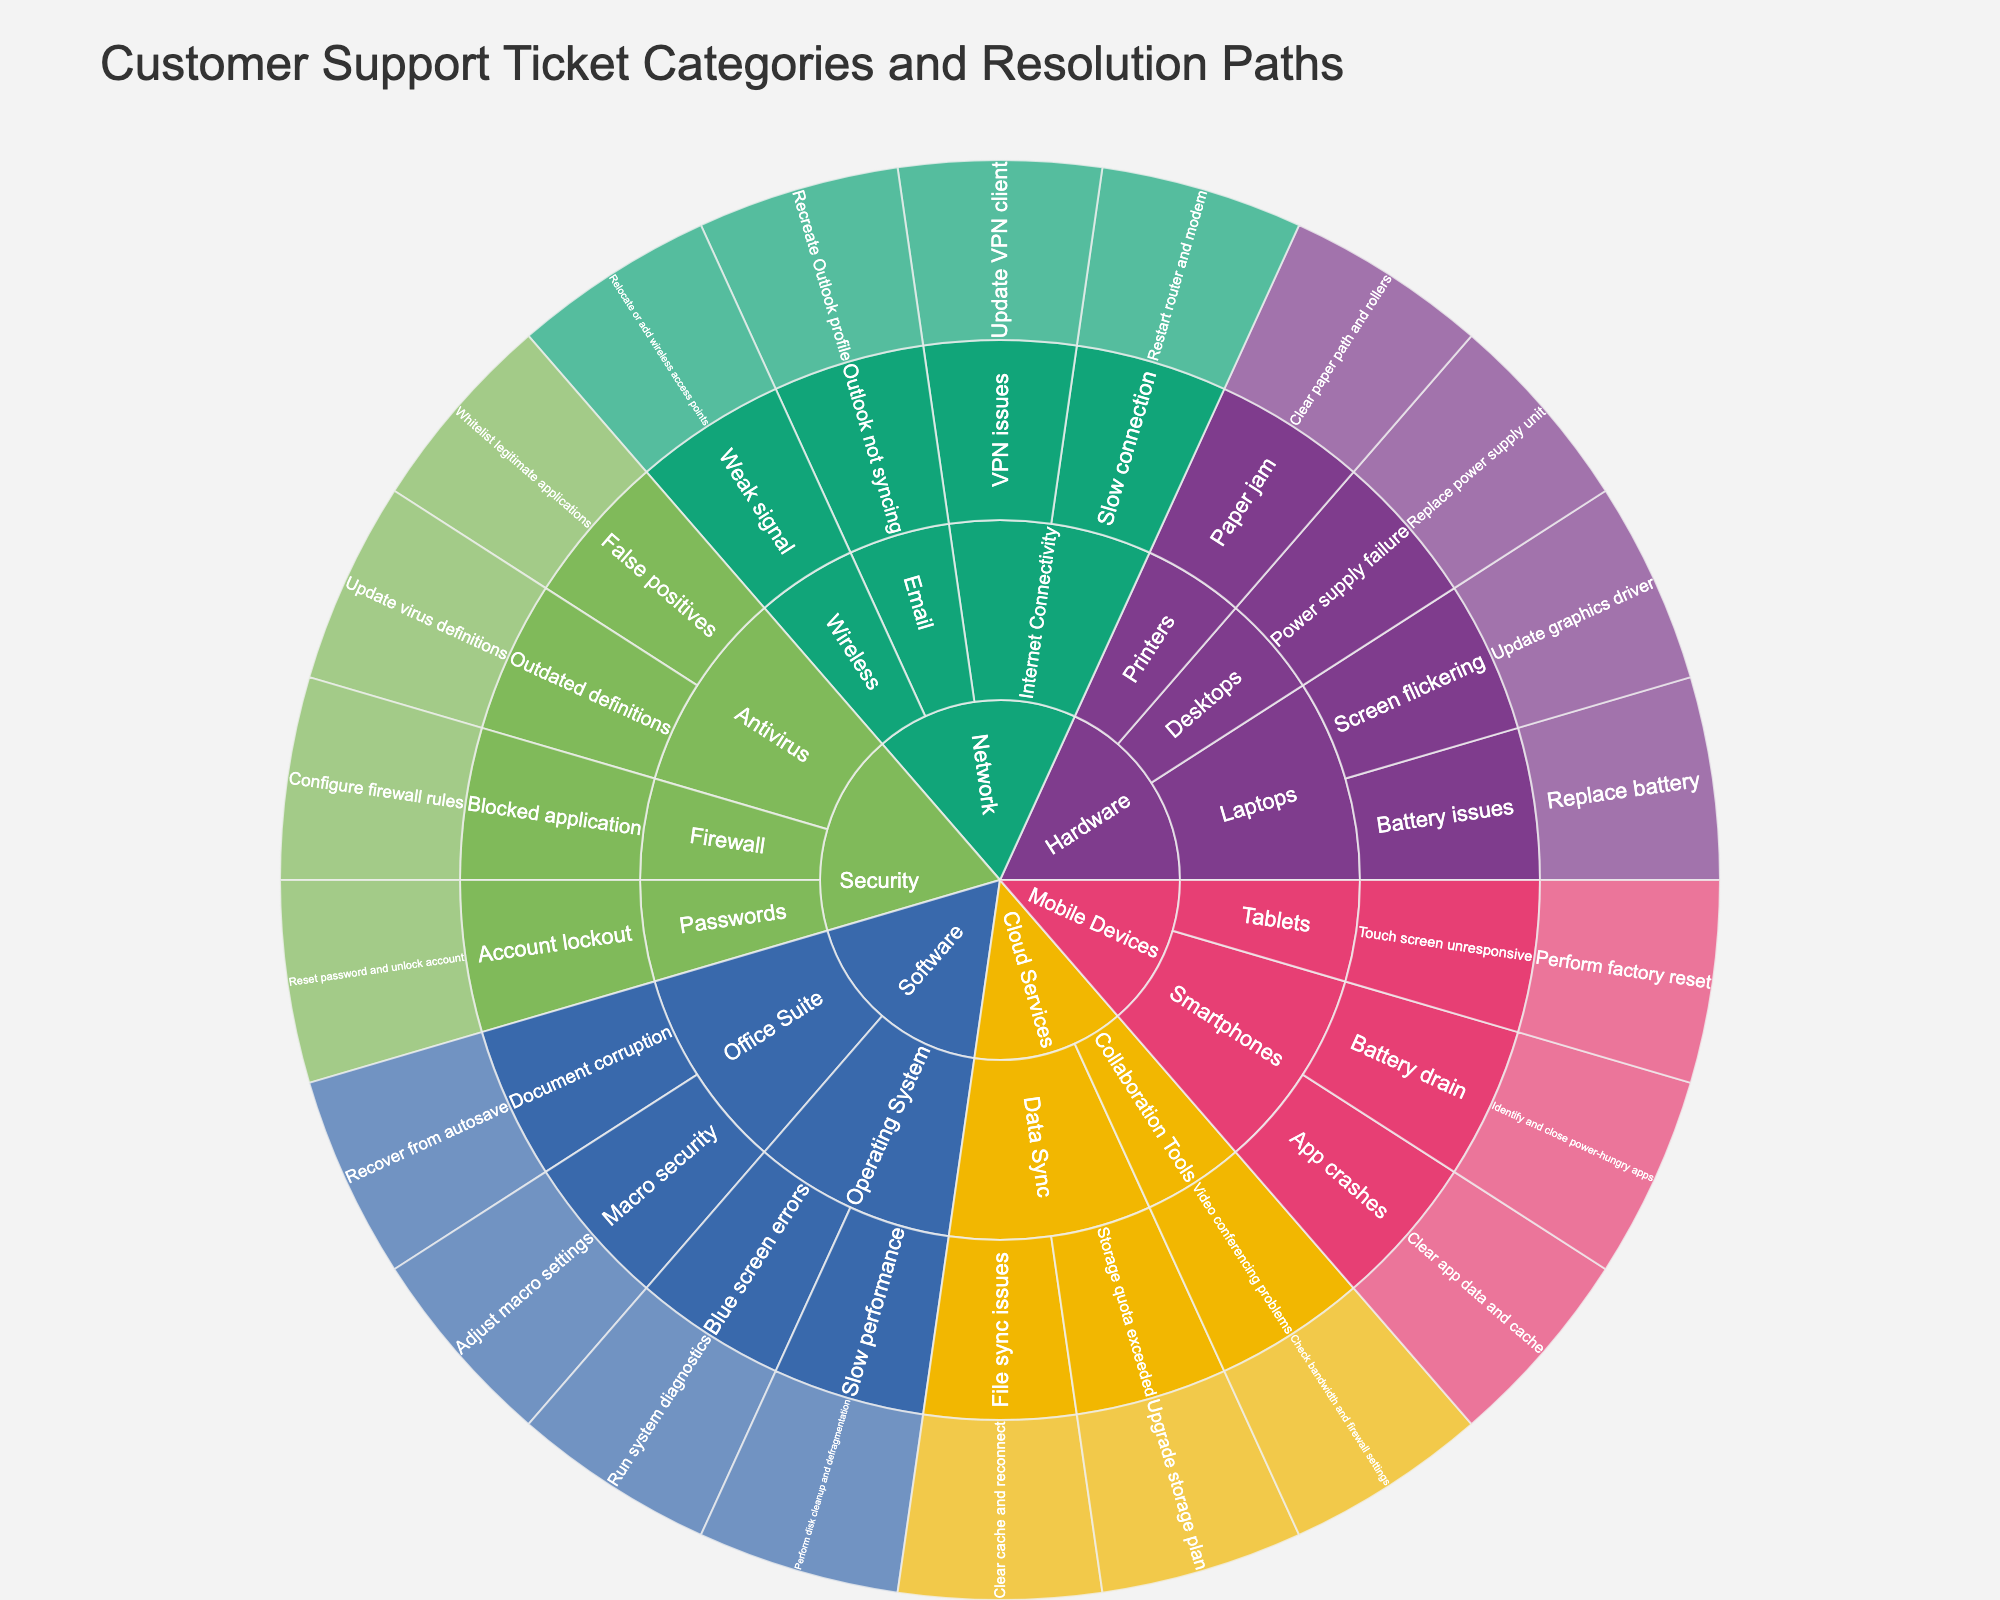What is the title of the plot? The plot title is clearly visible at the top of the sunburst plot. It summarizes what the plot represents.
Answer: Customer Support Ticket Categories and Resolution Paths What category has the most subcategories? You can observe the number of subcategories by examining the segments branching out from each main category. Analyze each category to determine which has the most branches.
Answer: Network What issue is resolved by updating the virus definitions? Look within the "Security" category, navigate through the "Antivirus" subcategory, and look for the issue linked to the "Update virus definitions" resolution.
Answer: Outdated definitions How many issues are listed under the "Hardware" category? Check all the subcategories within the "Hardware" category and count all the distinct issues listed.
Answer: Four Which subcategory under "Mobile Devices" has more issues? Compare the number of issues within the "Smartphones" and "Tablets" subcategories.
Answer: Smartphones What common issue is found under both "Laptops" and "Smartphones" subcategories? Compare the issues listed under "Laptops" and "Smartphones" subcategories to identify if any issue appears in both.
Answer: Battery issues What is the resolution for "VPN issues" in the "Network" category? Navigate to the "Network" category, look under "Internet Connectivity" subcategory, and find the resolution for "VPN issues".
Answer: Update VPN client How does the complexity of resolutions compare between the "Software" and "Security" categories? Evaluate and compare the resolution steps listed under the "Software" and "Security" categories to determine which has more complex steps (e.g., multiple actions or more technical processes).
Answer: Security category resolutions are generally more complex Which resolution under "Cloud Services" requires upgrading a plan? Under the "Cloud Services" category, look for the resolution which mentions upgrading a plan in the "Data Sync" subcategory.
Answer: Storage quota exceeded What's the main difference in the subcategory structure between "Software" and "Mobile Devices"? Analyze and compare the branching structure of subcategories under "Software" and "Mobile Devices", focusing on the number and nature of subcategories.
Answer: "Software" has a broader range of system-related subcategories, while "Mobile Devices" focuses more on device-specific issues 